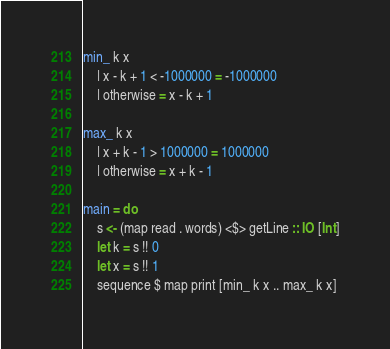Convert code to text. <code><loc_0><loc_0><loc_500><loc_500><_Haskell_>min_ k x
    | x - k + 1 < -1000000 = -1000000
    | otherwise = x - k + 1

max_ k x
    | x + k - 1 > 1000000 = 1000000
    | otherwise = x + k - 1

main = do
    s <- (map read . words) <$> getLine :: IO [Int]
    let k = s !! 0
    let x = s !! 1
    sequence $ map print [min_ k x .. max_ k x]</code> 